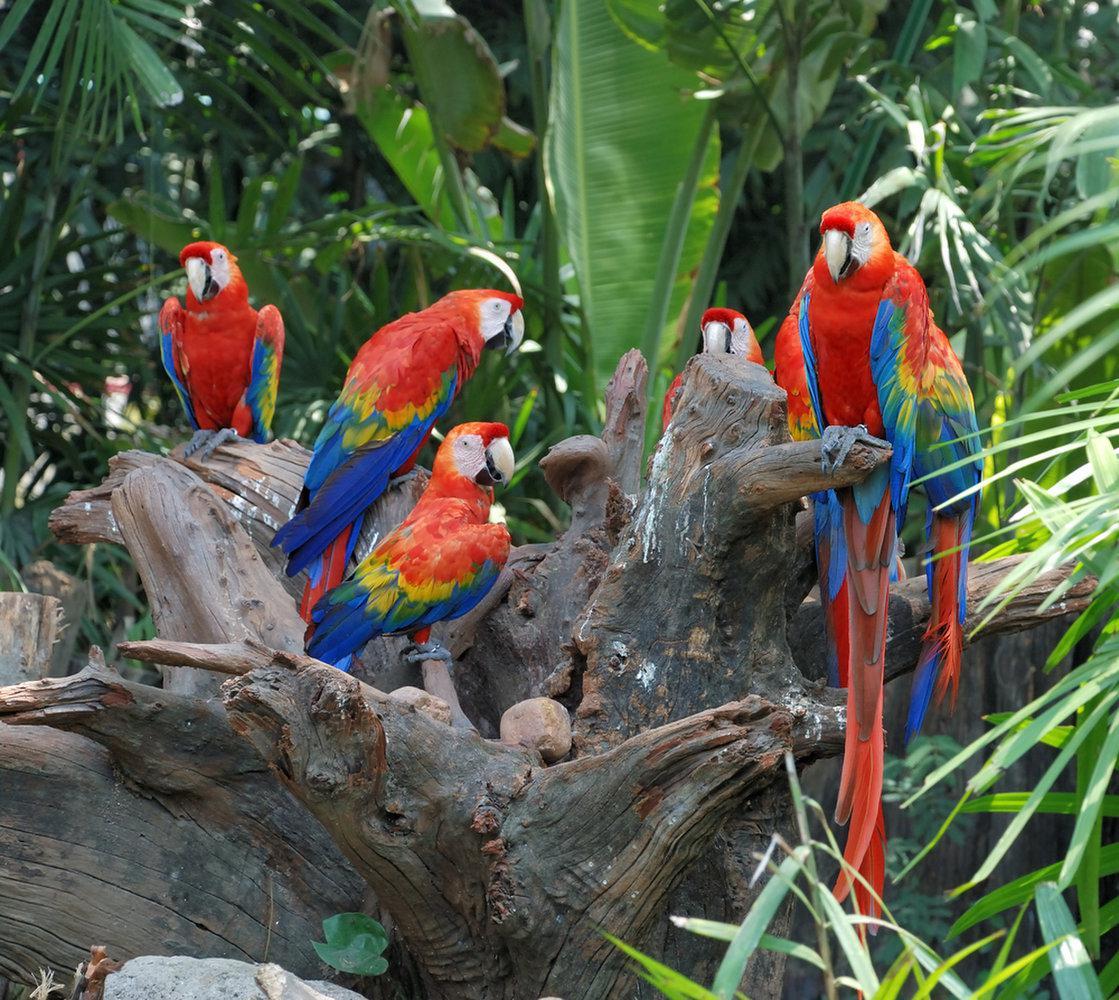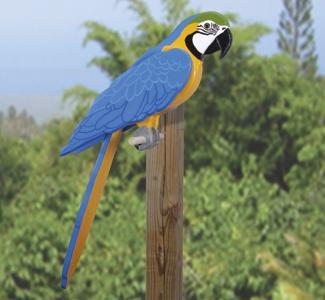The first image is the image on the left, the second image is the image on the right. Given the left and right images, does the statement "An image contains various parrots perched on a humans arms and shoulders." hold true? Answer yes or no. No. The first image is the image on the left, the second image is the image on the right. Evaluate the accuracy of this statement regarding the images: "The combined images show two people with parrots perched on various parts of their bodies.". Is it true? Answer yes or no. No. 